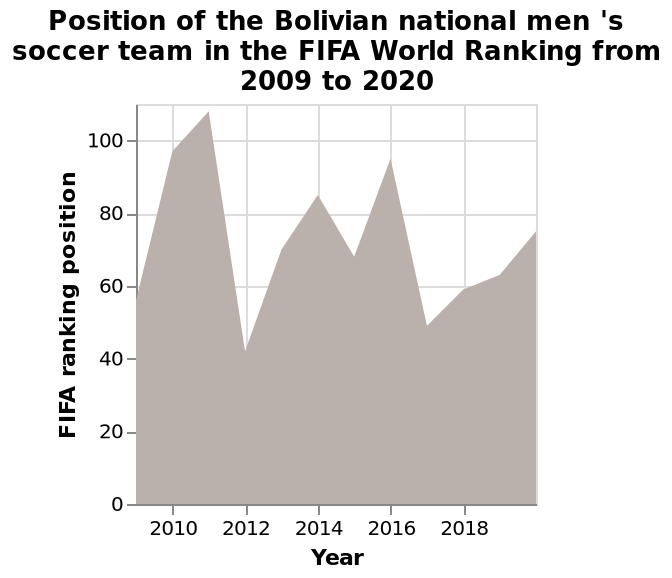<image>
Offer a thorough analysis of the image. The position of the Bolivian national men's soccer team in the FIFA World Ranking has been inconsistent between 2009 and 2020. In 2011 it reached it's lowest ranking of 100+, followed by it's highest ranking of approximately 40 the following year in 2012. How often does the rank of the Bolivian men's football team change? The rank of the Bolivian men's football team can change from year to year, as seen in the drastic difference between their highest and lowest rankings. When was the starting point of the data for the FIFA World Ranking of the Bolivian national men's soccer team?  The starting point of the data for the FIFA World Ranking of the Bolivian national men's soccer team was in 2009. At which year did the Bolivian national men's soccer team achieve its highest FIFA ranking position? The Bolivian national men's soccer team achieved its highest FIFA ranking position in a specific year between 2009 and 2020. 